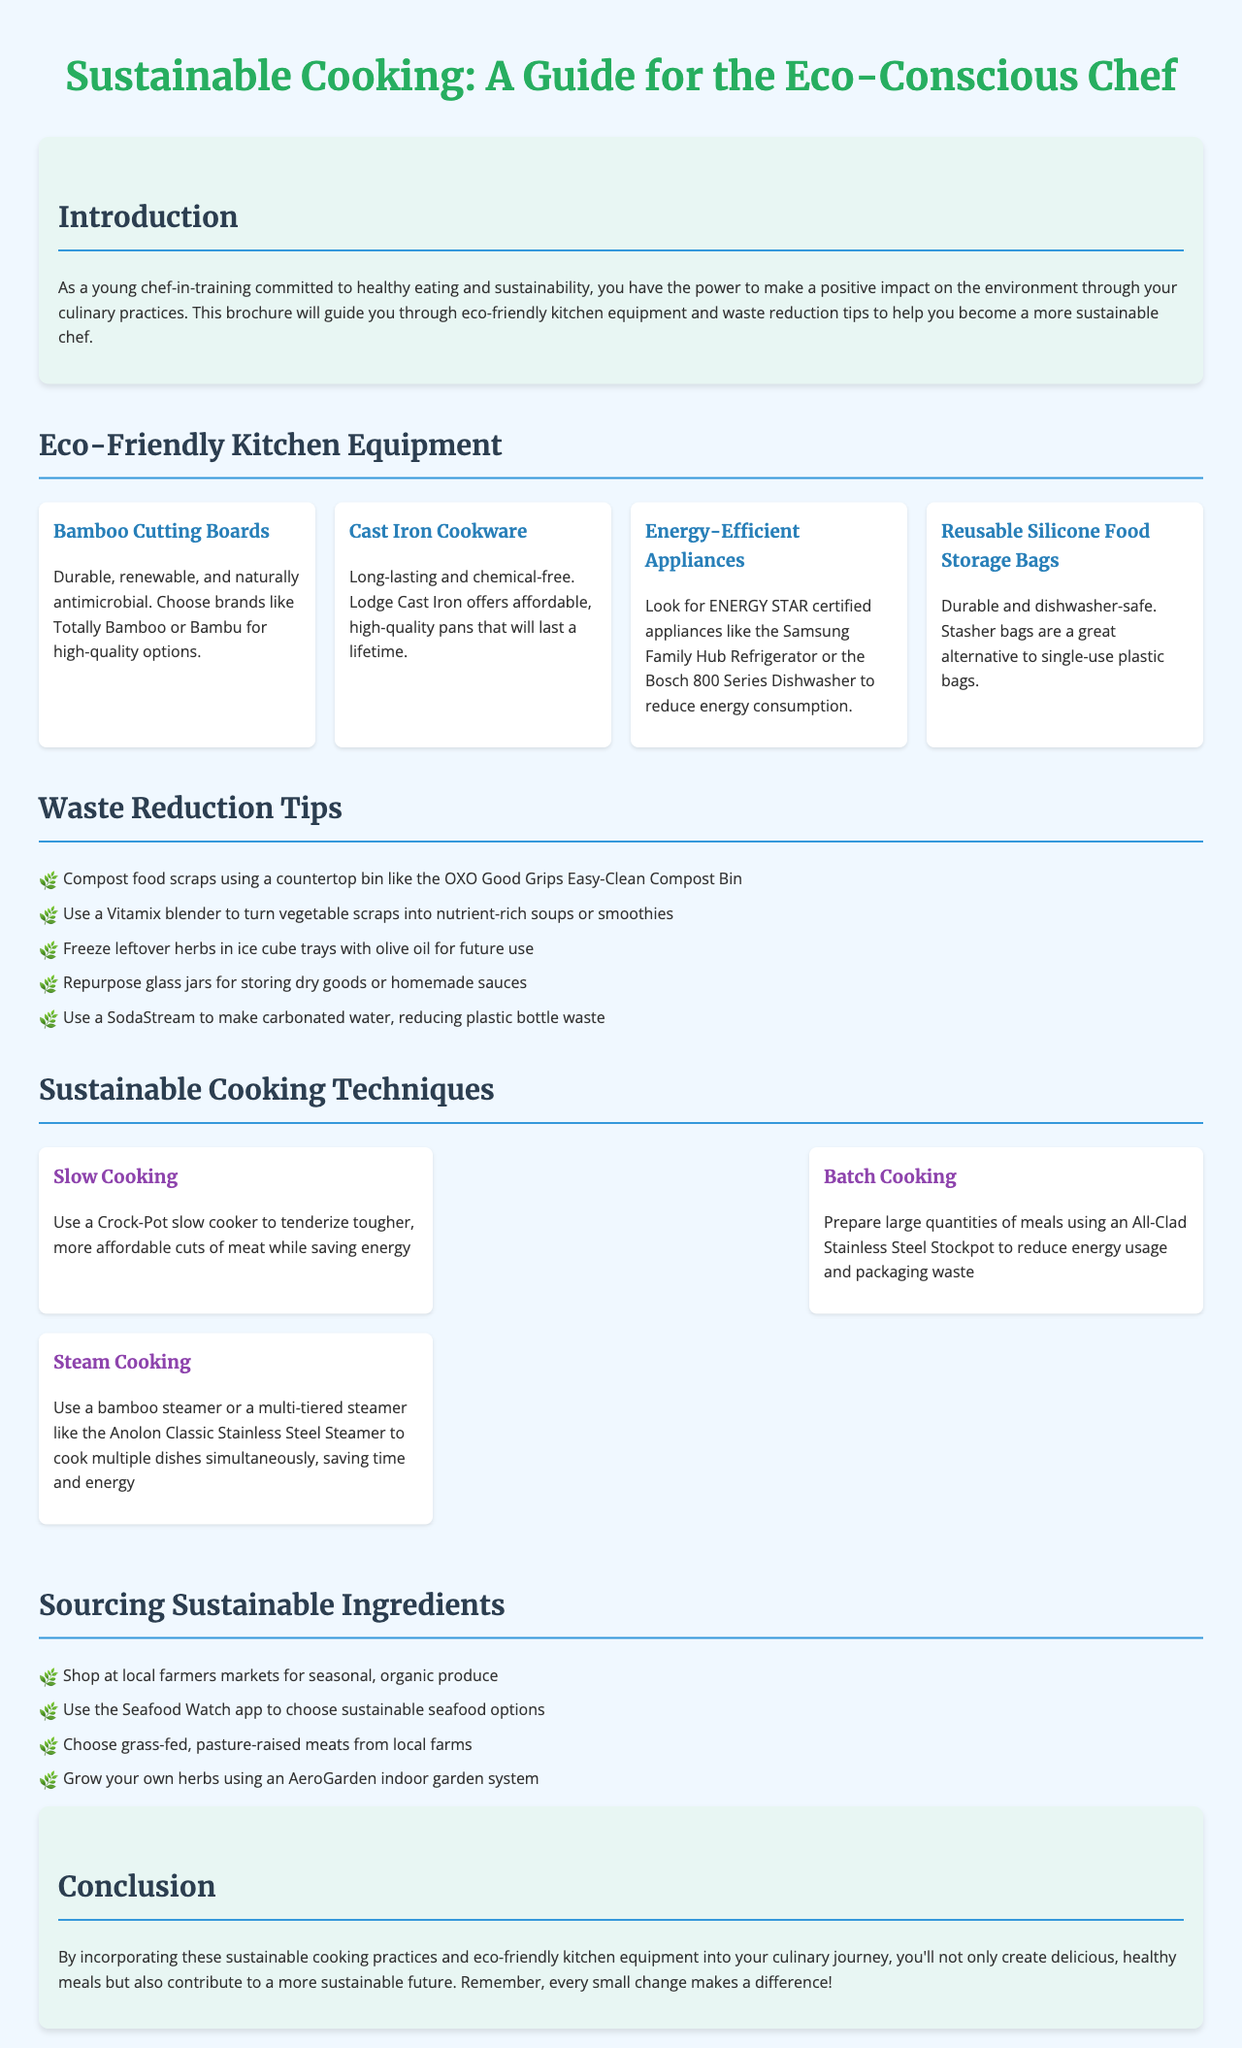what is the title of the brochure? The title of the brochure is displayed prominently at the top of the document.
Answer: Sustainable Cooking: A Guide for the Eco-Conscious Chef what is a recommended eco-friendly kitchen equipment? The brochure lists several eco-friendly kitchen item options under the Eco-Friendly Kitchen Equipment section.
Answer: Bamboo Cutting Boards how many waste reduction tips are provided in the document? The Waste Reduction Tips section contains a specific number of listed items.
Answer: 5 which cooking technique uses a multi-tiered steamer? The Sustainable Cooking Techniques section describes various methods, and one specifically mentions a multi-tiered steamer.
Answer: Steam Cooking what is one method to source sustainable ingredients? The Sourcing Sustainable Ingredients section offers several strategies.
Answer: Shop at local farmers markets what is the main focus of the brochure? The introduction clearly states the main aim of the brochure for its readers.
Answer: Eco-friendly kitchen practices what should you do with leftover herbs according to the brochure? The Waste Reduction Tips section provides specific advice regarding leftover herbs.
Answer: Freeze leftover herbs in ice cube trays with olive oil for future use which brand is recommended for cast iron cookware? Specific brands are mentioned in the Eco-Friendly Kitchen Equipment section.
Answer: Lodge Cast Iron how do you turn vegetable scraps into another dish? This relates to a specific tip in the Waste Reduction Tips section.
Answer: Use a Vitamix blender to turn vegetable scraps into nutrient-rich soups or smoothies 